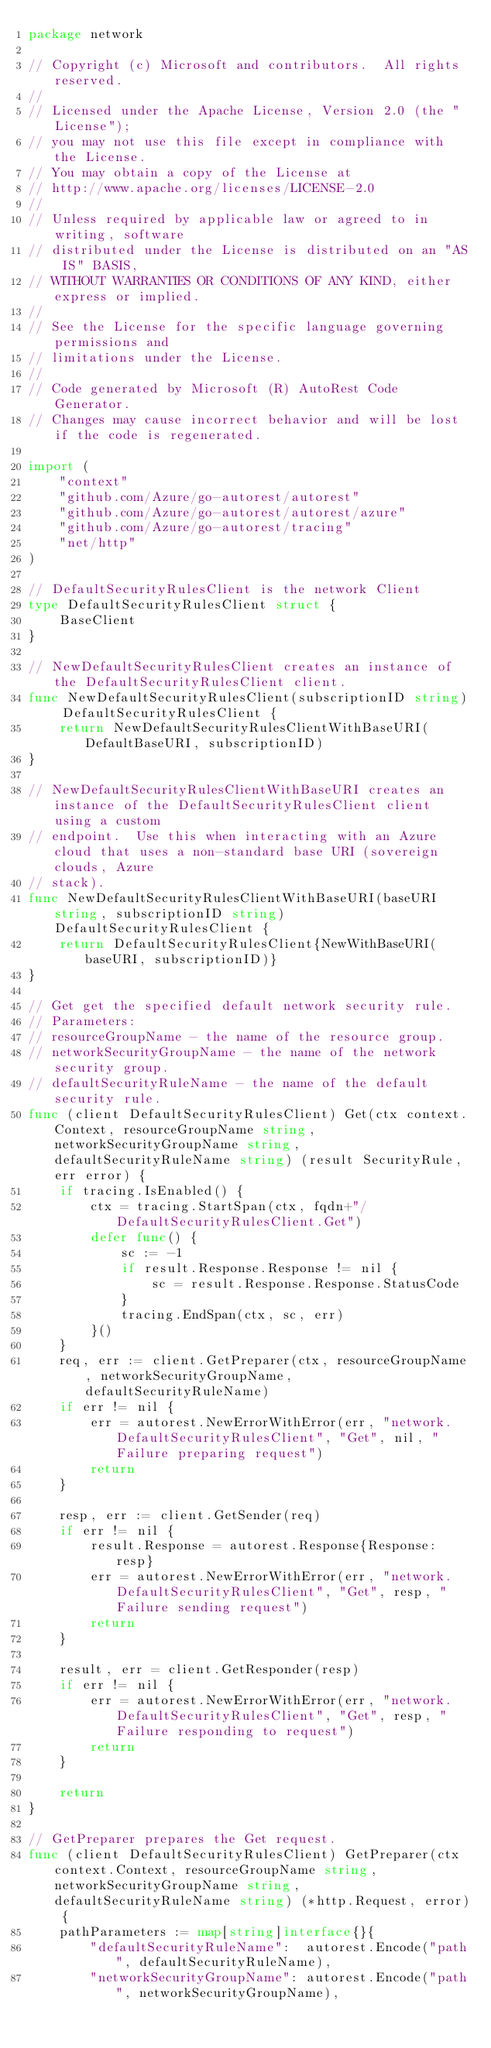Convert code to text. <code><loc_0><loc_0><loc_500><loc_500><_Go_>package network

// Copyright (c) Microsoft and contributors.  All rights reserved.
//
// Licensed under the Apache License, Version 2.0 (the "License");
// you may not use this file except in compliance with the License.
// You may obtain a copy of the License at
// http://www.apache.org/licenses/LICENSE-2.0
//
// Unless required by applicable law or agreed to in writing, software
// distributed under the License is distributed on an "AS IS" BASIS,
// WITHOUT WARRANTIES OR CONDITIONS OF ANY KIND, either express or implied.
//
// See the License for the specific language governing permissions and
// limitations under the License.
//
// Code generated by Microsoft (R) AutoRest Code Generator.
// Changes may cause incorrect behavior and will be lost if the code is regenerated.

import (
	"context"
	"github.com/Azure/go-autorest/autorest"
	"github.com/Azure/go-autorest/autorest/azure"
	"github.com/Azure/go-autorest/tracing"
	"net/http"
)

// DefaultSecurityRulesClient is the network Client
type DefaultSecurityRulesClient struct {
	BaseClient
}

// NewDefaultSecurityRulesClient creates an instance of the DefaultSecurityRulesClient client.
func NewDefaultSecurityRulesClient(subscriptionID string) DefaultSecurityRulesClient {
	return NewDefaultSecurityRulesClientWithBaseURI(DefaultBaseURI, subscriptionID)
}

// NewDefaultSecurityRulesClientWithBaseURI creates an instance of the DefaultSecurityRulesClient client using a custom
// endpoint.  Use this when interacting with an Azure cloud that uses a non-standard base URI (sovereign clouds, Azure
// stack).
func NewDefaultSecurityRulesClientWithBaseURI(baseURI string, subscriptionID string) DefaultSecurityRulesClient {
	return DefaultSecurityRulesClient{NewWithBaseURI(baseURI, subscriptionID)}
}

// Get get the specified default network security rule.
// Parameters:
// resourceGroupName - the name of the resource group.
// networkSecurityGroupName - the name of the network security group.
// defaultSecurityRuleName - the name of the default security rule.
func (client DefaultSecurityRulesClient) Get(ctx context.Context, resourceGroupName string, networkSecurityGroupName string, defaultSecurityRuleName string) (result SecurityRule, err error) {
	if tracing.IsEnabled() {
		ctx = tracing.StartSpan(ctx, fqdn+"/DefaultSecurityRulesClient.Get")
		defer func() {
			sc := -1
			if result.Response.Response != nil {
				sc = result.Response.Response.StatusCode
			}
			tracing.EndSpan(ctx, sc, err)
		}()
	}
	req, err := client.GetPreparer(ctx, resourceGroupName, networkSecurityGroupName, defaultSecurityRuleName)
	if err != nil {
		err = autorest.NewErrorWithError(err, "network.DefaultSecurityRulesClient", "Get", nil, "Failure preparing request")
		return
	}

	resp, err := client.GetSender(req)
	if err != nil {
		result.Response = autorest.Response{Response: resp}
		err = autorest.NewErrorWithError(err, "network.DefaultSecurityRulesClient", "Get", resp, "Failure sending request")
		return
	}

	result, err = client.GetResponder(resp)
	if err != nil {
		err = autorest.NewErrorWithError(err, "network.DefaultSecurityRulesClient", "Get", resp, "Failure responding to request")
		return
	}

	return
}

// GetPreparer prepares the Get request.
func (client DefaultSecurityRulesClient) GetPreparer(ctx context.Context, resourceGroupName string, networkSecurityGroupName string, defaultSecurityRuleName string) (*http.Request, error) {
	pathParameters := map[string]interface{}{
		"defaultSecurityRuleName":  autorest.Encode("path", defaultSecurityRuleName),
		"networkSecurityGroupName": autorest.Encode("path", networkSecurityGroupName),</code> 